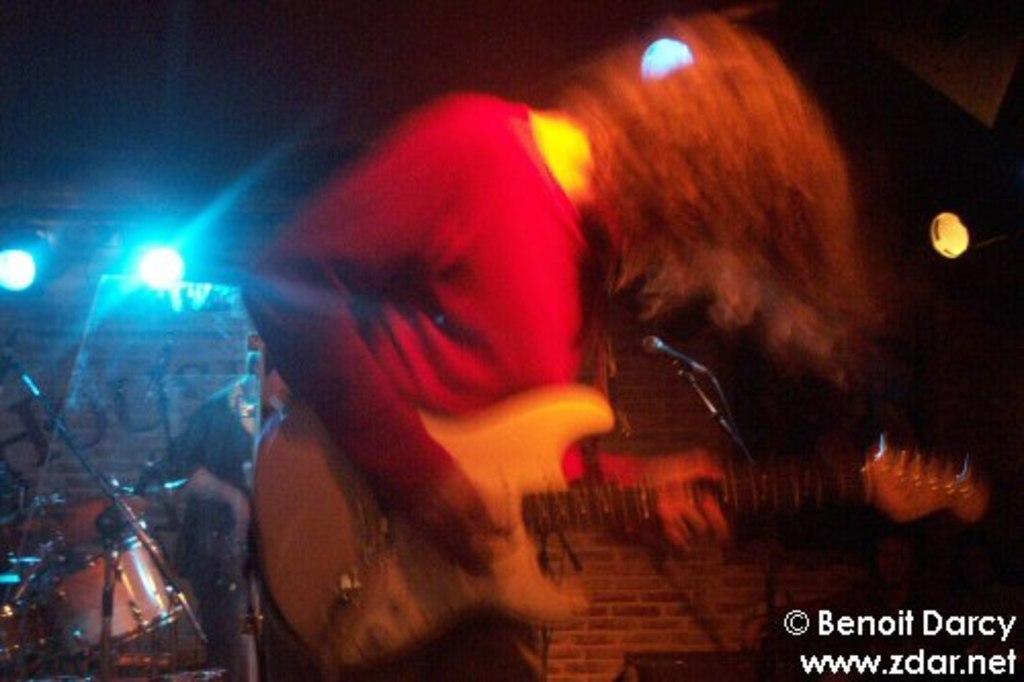Describe this image in one or two sentences. In the image we can see there are women who is standing and holding guitar in her hand. 